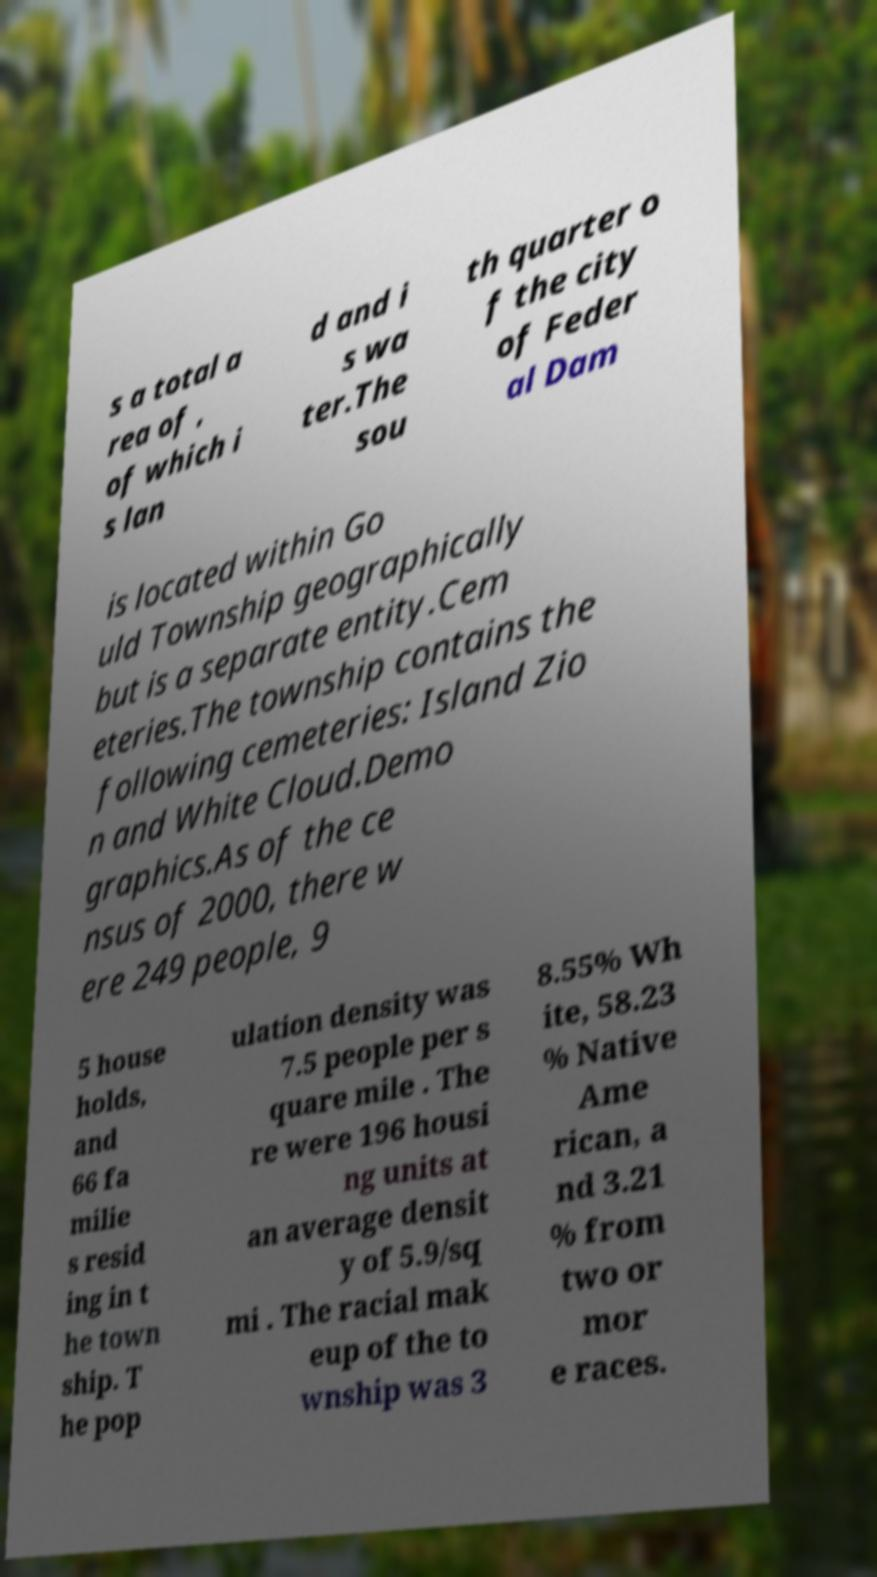For documentation purposes, I need the text within this image transcribed. Could you provide that? s a total a rea of , of which i s lan d and i s wa ter.The sou th quarter o f the city of Feder al Dam is located within Go uld Township geographically but is a separate entity.Cem eteries.The township contains the following cemeteries: Island Zio n and White Cloud.Demo graphics.As of the ce nsus of 2000, there w ere 249 people, 9 5 house holds, and 66 fa milie s resid ing in t he town ship. T he pop ulation density was 7.5 people per s quare mile . The re were 196 housi ng units at an average densit y of 5.9/sq mi . The racial mak eup of the to wnship was 3 8.55% Wh ite, 58.23 % Native Ame rican, a nd 3.21 % from two or mor e races. 